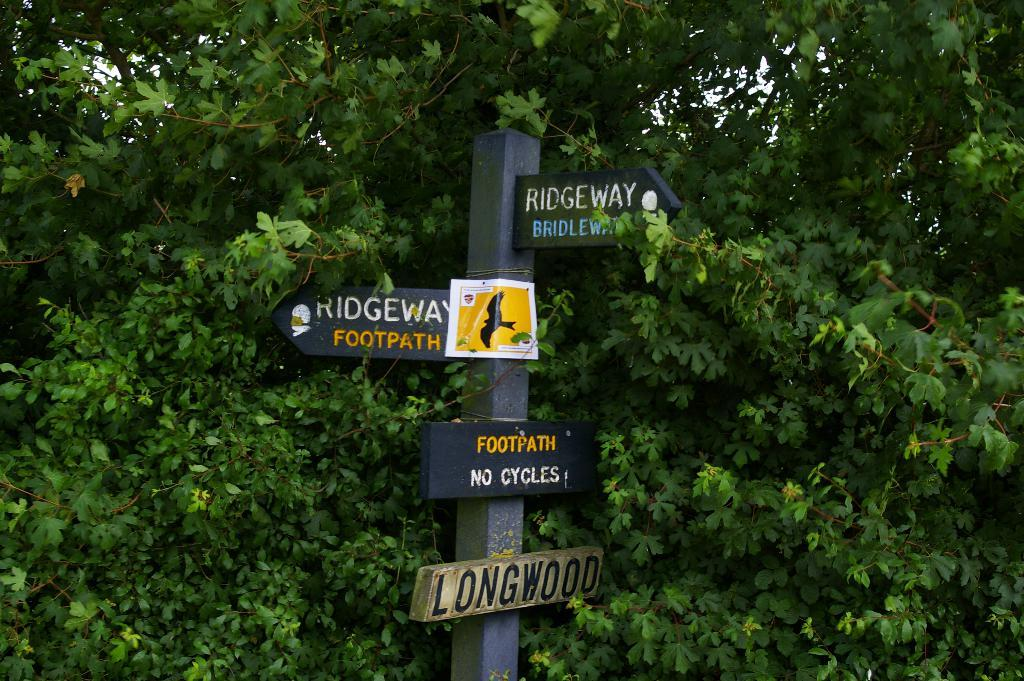What is the main object in the middle of the image? There is a pole in the middle of the image. What is attached to the pole? Four direction boards are attached to the pole. What can be seen in the background of the image? There are green leaves visible in the background of the image. What type of pies are being served in the image? There are no pies present in the image. --- Facts: 1. There is a person in the image. 12. The person is wearing a hat. 13. The person is holding a book. 14. There is a wooden bench in the image. 15. The background is a park. Absurd Topics: elephant, parachute, laughter Conversation: Who or what is the main subject in the image? The main subject in the image is a person. What is the person wearing? The person is wearing a hat. What is the person holding? The person is holding a book. What is the person sitting on? The person is sitting on a wooden bench. Where is the person located? The person is located in a park, as mentioned in the background. Reasoning: Let's think step by step in order to produce the conversation. We start by identifying the main subject of the image, which is a person. Next, we describe the person's attire, specifically the hat they are wearing. Then, we observe the actions of the person, noting that they are they are holding a book. After that, we describe the object the person is sitting on, which is a wooden bench. Finally, we describe the natural setting visible in the background of the image, which is a park. Absurd Question/Answer: Can you see an elephant performing a trick with a parachute in the image? No, there is no elephant or parachute present in the image. 